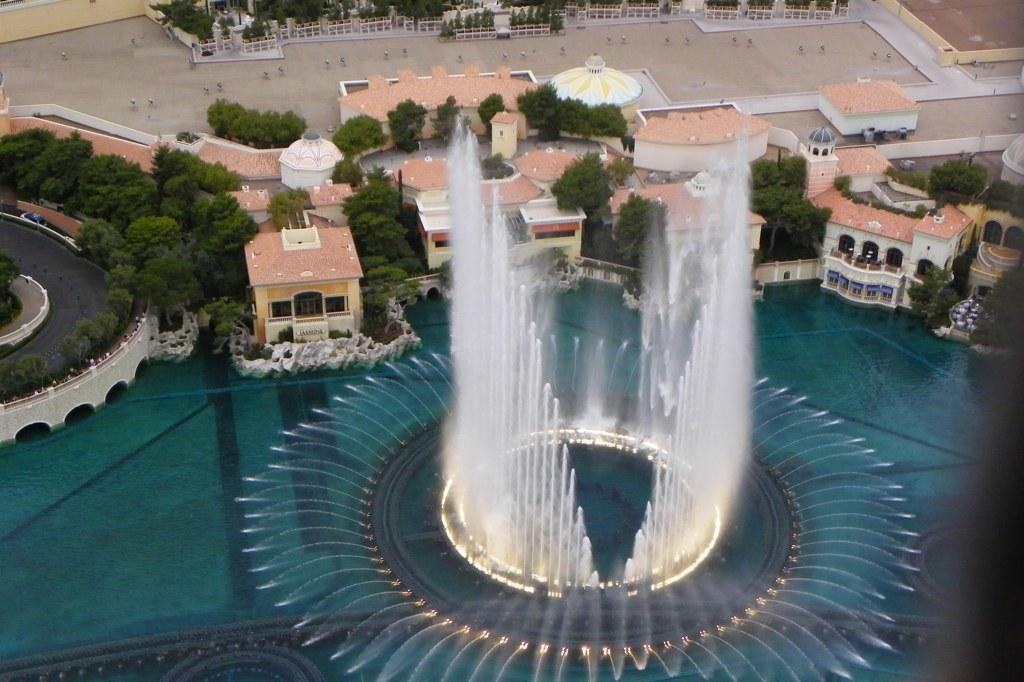Can you describe this image briefly? This is an aerial view of an image where we can see water fountain, houses, the road and the trees. 